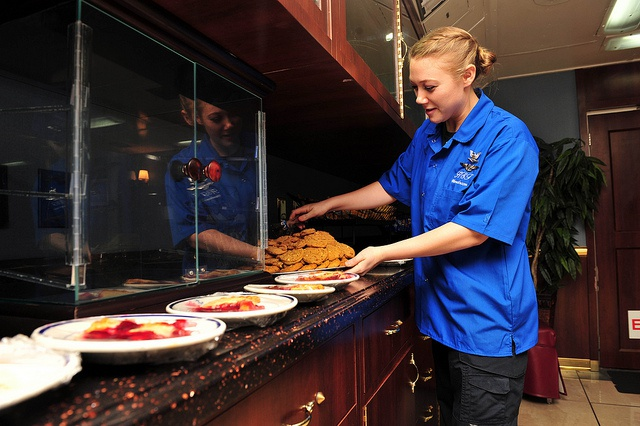Describe the objects in this image and their specific colors. I can see people in black, blue, darkblue, and tan tones and potted plant in black, maroon, and gray tones in this image. 